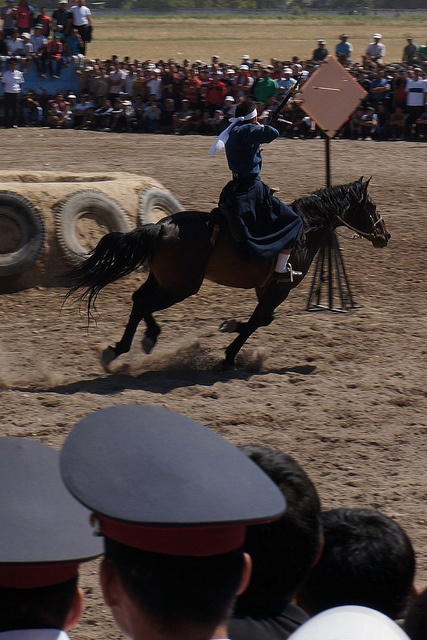Describe the objects in this image and their specific colors. I can see people in darkgreen, black, gray, lightgray, and maroon tones, people in darkgreen, gray, black, and maroon tones, horse in darkgreen, black, gray, and maroon tones, people in darkgreen, black, and gray tones, and people in darkgreen, black, and gray tones in this image. 